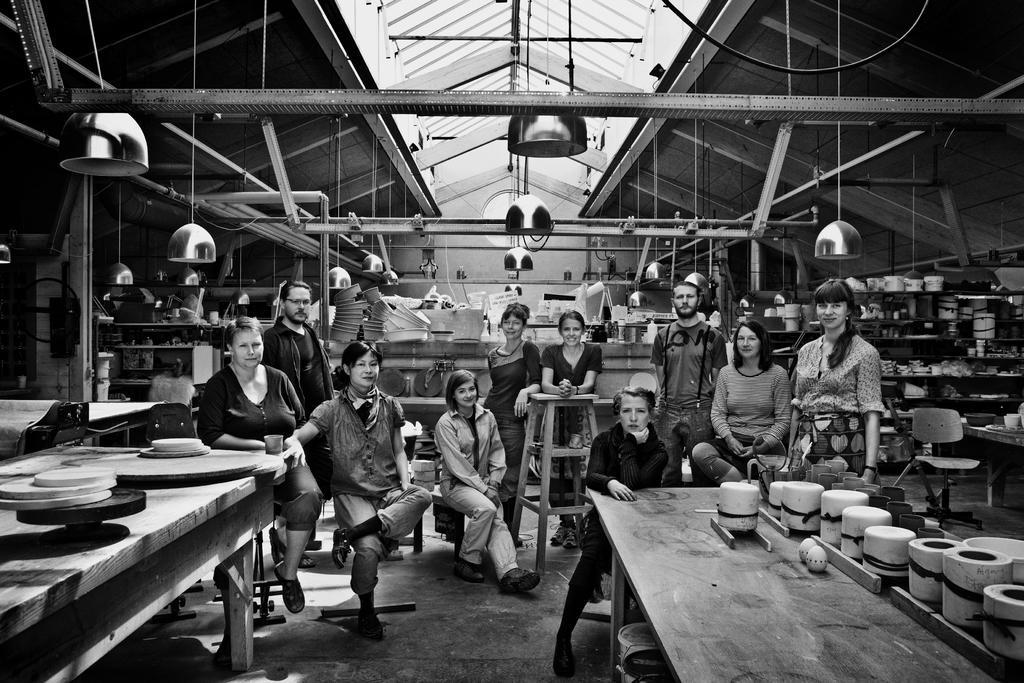Describe this image in one or two sentences. In this image I can see number of people were few of them are sitting and rest all are standing. In the background I can see few lights. 